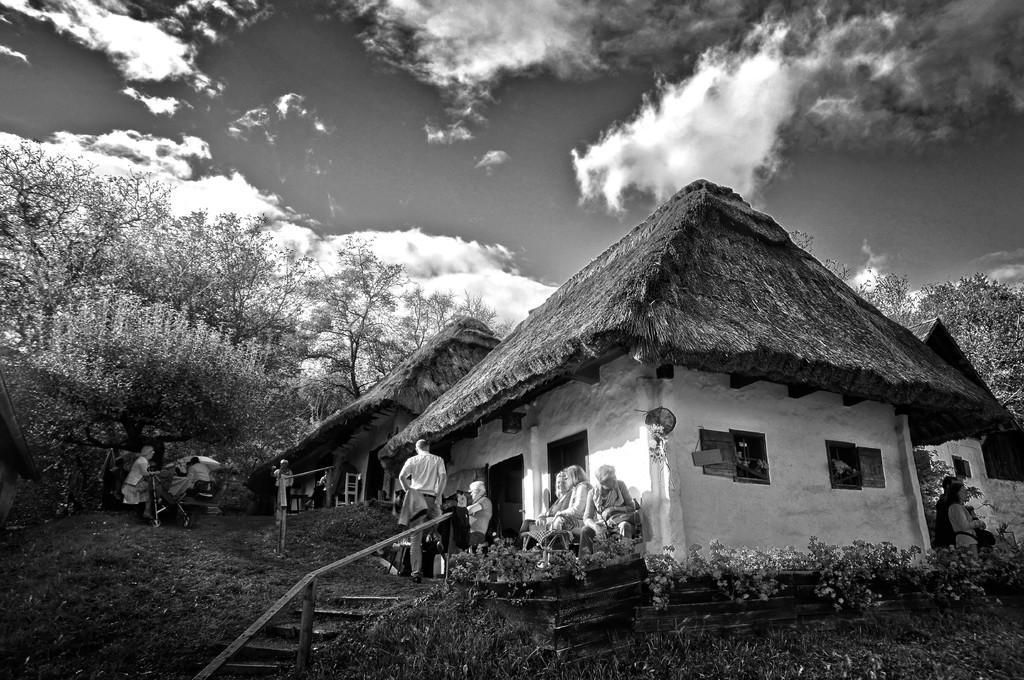Can you describe this image briefly? In this image we can see a black and white picture of few houses and people near the house and there are stairs with railing, there are few plants in front of the house, there are few trees and the sky with cloud in the background. 